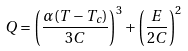<formula> <loc_0><loc_0><loc_500><loc_500>Q = { \left ( \frac { \alpha ( T - T _ { c } ) } { 3 C } \right ) } ^ { 3 } + { \left ( \frac { E } { 2 C } \right ) } ^ { 2 }</formula> 